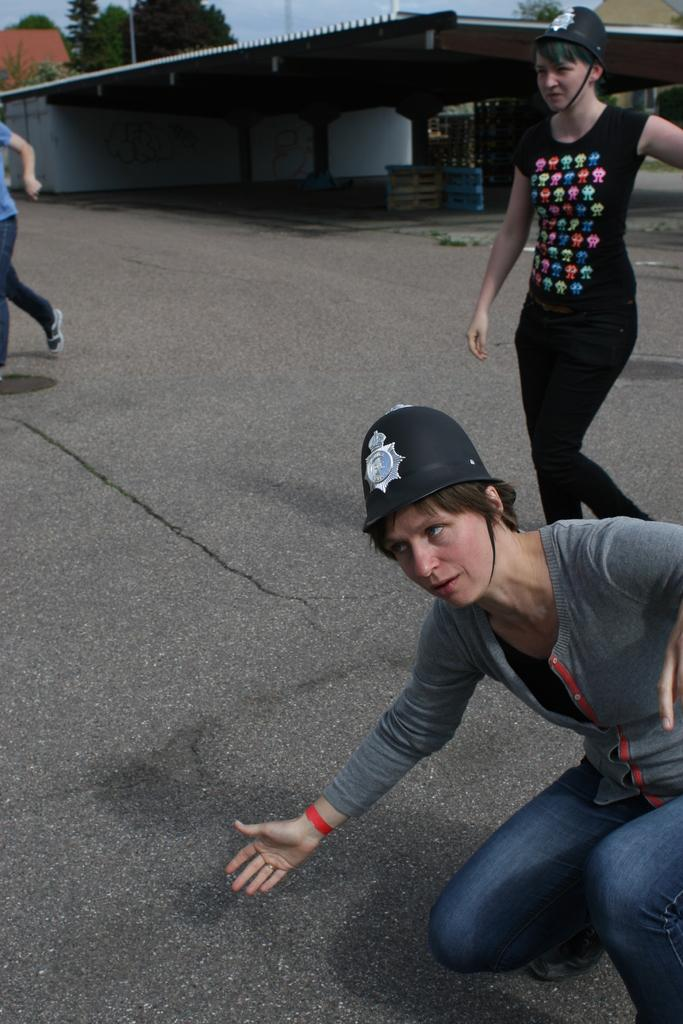What are the two persons in the image doing? The two persons in the image are walking on the road. What position is the third person in? The third person is in a squat position. What can be seen in the background of the image? There is a shed, houses, trees, and the sky visible in the background. What type of locket is the person wearing in the image? There is no locket visible on any person in the image. What furniture can be seen in the image? There is no furniture present in the image. 